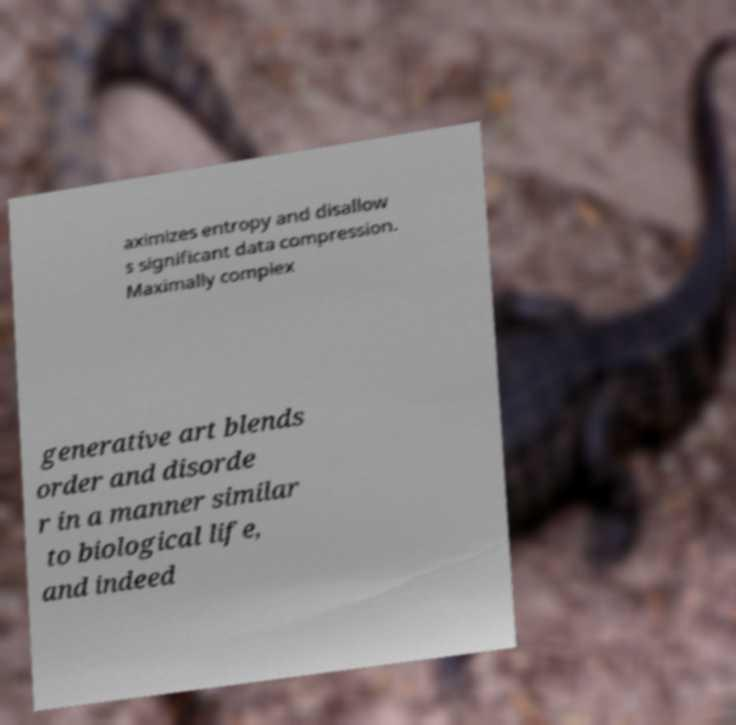There's text embedded in this image that I need extracted. Can you transcribe it verbatim? aximizes entropy and disallow s significant data compression. Maximally complex generative art blends order and disorde r in a manner similar to biological life, and indeed 